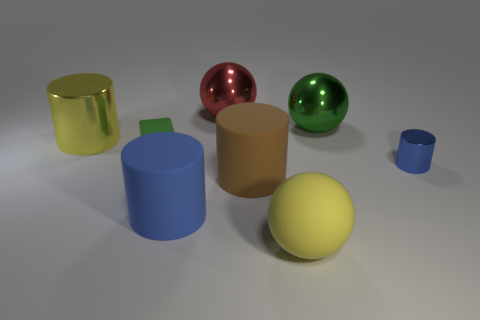Add 1 yellow rubber things. How many objects exist? 9 Subtract all large yellow matte spheres. How many spheres are left? 2 Subtract 1 balls. How many balls are left? 2 Subtract all brown cylinders. How many cylinders are left? 3 Subtract all cubes. How many objects are left? 7 Subtract all yellow rubber objects. Subtract all blue metal objects. How many objects are left? 6 Add 6 green metallic spheres. How many green metallic spheres are left? 7 Add 4 green things. How many green things exist? 6 Subtract 1 green cubes. How many objects are left? 7 Subtract all cyan cylinders. Subtract all yellow balls. How many cylinders are left? 4 